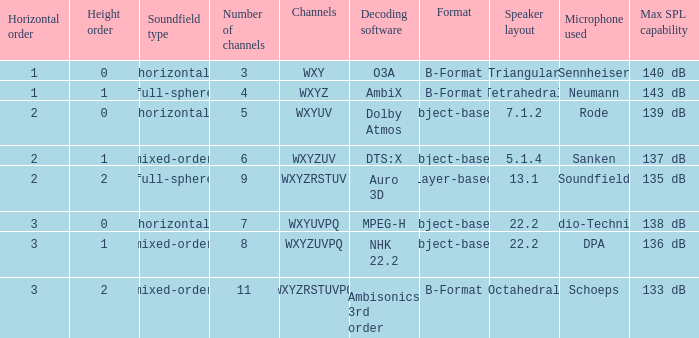If the channels is wxyzuv, what is the number of channels? 6.0. 